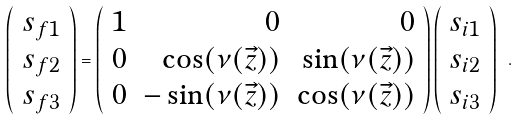<formula> <loc_0><loc_0><loc_500><loc_500>\left ( \begin{array} { c } s _ { f 1 } \\ s _ { f 2 } \\ s _ { f 3 } \end{array} \right ) = \left ( \begin{array} { r r r } 1 & 0 & 0 \\ 0 & \cos ( \nu ( \vec { z } ) ) & \sin ( \nu ( \vec { z } ) ) \\ 0 & - \sin ( \nu ( \vec { z } ) ) & \cos ( \nu ( \vec { z } ) ) \end{array} \right ) \left ( \begin{array} { c } s _ { i 1 } \\ s _ { i 2 } \\ s _ { i 3 } \end{array} \right ) \ .</formula> 